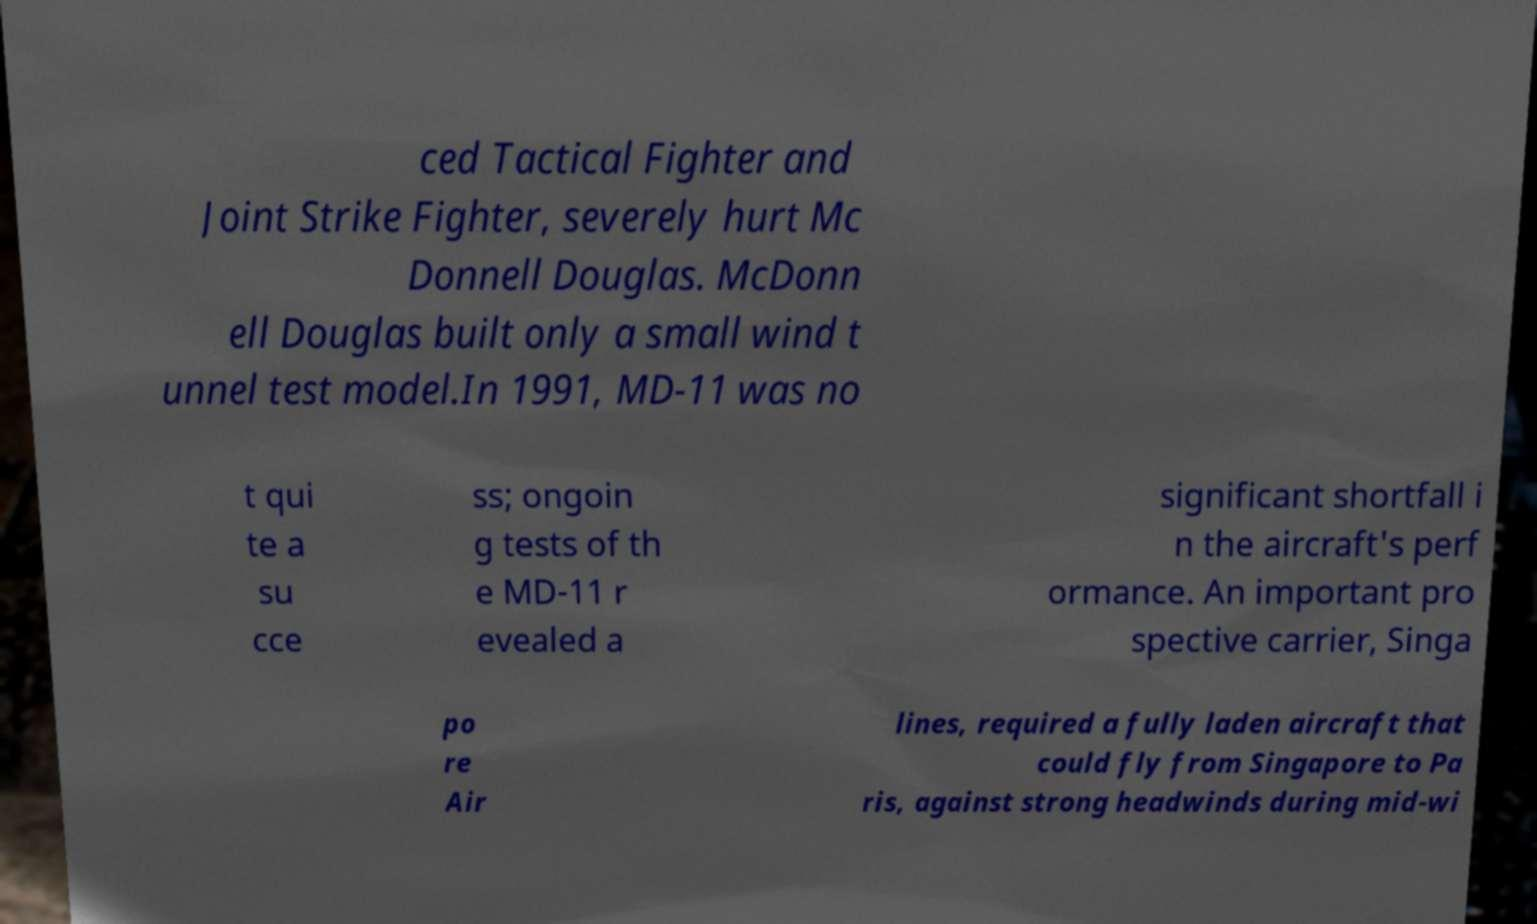Please read and relay the text visible in this image. What does it say? ced Tactical Fighter and Joint Strike Fighter, severely hurt Mc Donnell Douglas. McDonn ell Douglas built only a small wind t unnel test model.In 1991, MD-11 was no t qui te a su cce ss; ongoin g tests of th e MD-11 r evealed a significant shortfall i n the aircraft's perf ormance. An important pro spective carrier, Singa po re Air lines, required a fully laden aircraft that could fly from Singapore to Pa ris, against strong headwinds during mid-wi 